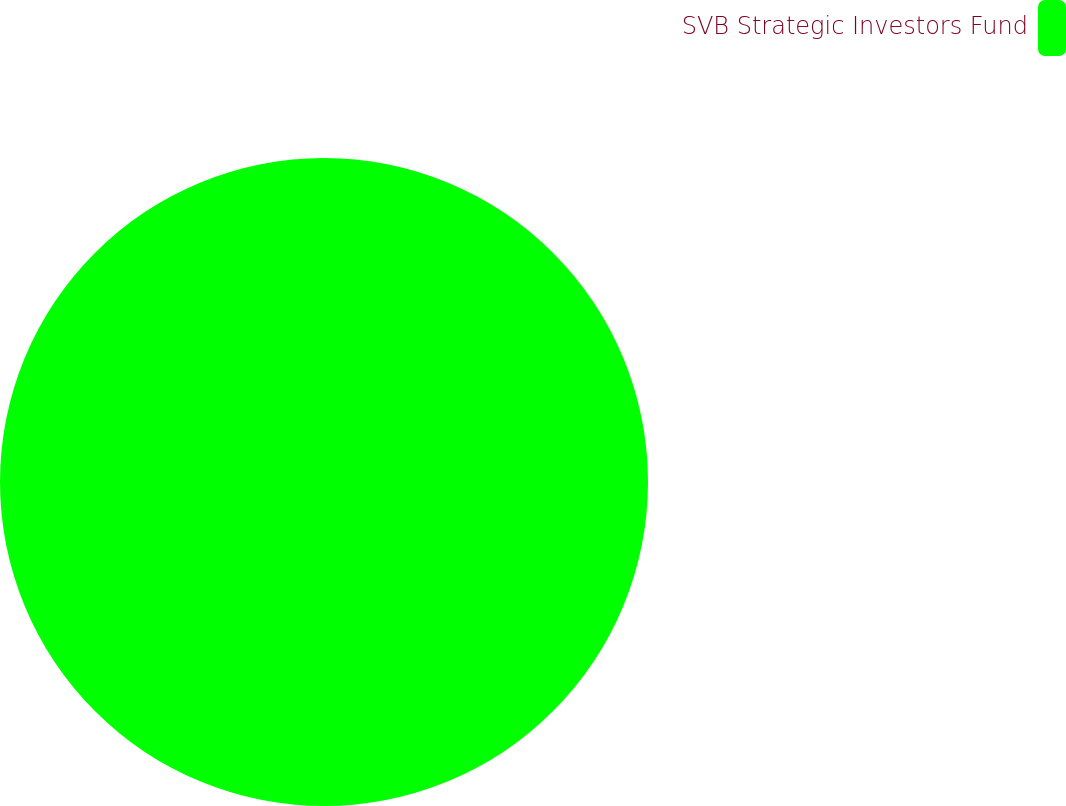Convert chart. <chart><loc_0><loc_0><loc_500><loc_500><pie_chart><fcel>SVB Strategic Investors Fund<nl><fcel>100.0%<nl></chart> 